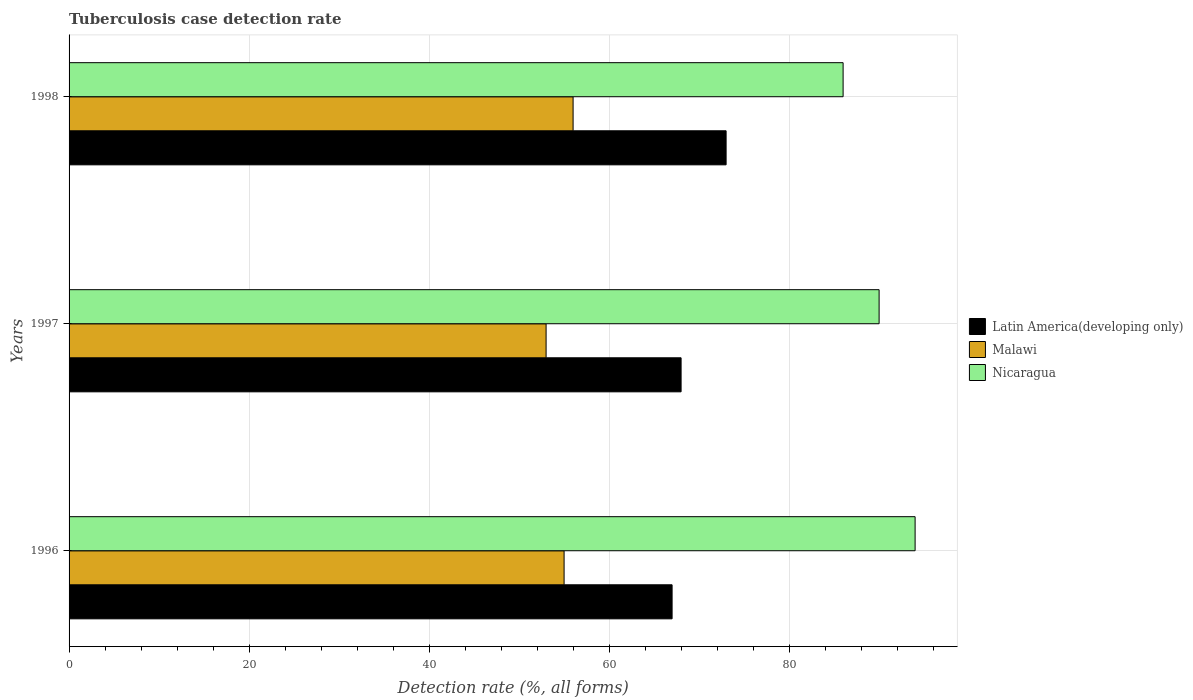How many different coloured bars are there?
Offer a terse response. 3. How many groups of bars are there?
Offer a very short reply. 3. Are the number of bars per tick equal to the number of legend labels?
Make the answer very short. Yes. In how many cases, is the number of bars for a given year not equal to the number of legend labels?
Give a very brief answer. 0. What is the tuberculosis case detection rate in in Nicaragua in 1998?
Your answer should be very brief. 86. Across all years, what is the maximum tuberculosis case detection rate in in Malawi?
Ensure brevity in your answer.  56. Across all years, what is the minimum tuberculosis case detection rate in in Malawi?
Provide a short and direct response. 53. What is the total tuberculosis case detection rate in in Nicaragua in the graph?
Make the answer very short. 270. What is the difference between the tuberculosis case detection rate in in Nicaragua in 1996 and that in 1998?
Offer a terse response. 8. What is the difference between the tuberculosis case detection rate in in Latin America(developing only) in 1996 and the tuberculosis case detection rate in in Malawi in 1998?
Your response must be concise. 11. What is the average tuberculosis case detection rate in in Latin America(developing only) per year?
Provide a succinct answer. 69.33. In the year 1998, what is the difference between the tuberculosis case detection rate in in Latin America(developing only) and tuberculosis case detection rate in in Nicaragua?
Ensure brevity in your answer.  -13. In how many years, is the tuberculosis case detection rate in in Nicaragua greater than 68 %?
Your response must be concise. 3. What is the ratio of the tuberculosis case detection rate in in Latin America(developing only) in 1996 to that in 1998?
Make the answer very short. 0.92. Is the tuberculosis case detection rate in in Nicaragua in 1996 less than that in 1997?
Offer a terse response. No. What is the difference between the highest and the second highest tuberculosis case detection rate in in Latin America(developing only)?
Give a very brief answer. 5. What is the difference between the highest and the lowest tuberculosis case detection rate in in Latin America(developing only)?
Keep it short and to the point. 6. Is the sum of the tuberculosis case detection rate in in Nicaragua in 1996 and 1997 greater than the maximum tuberculosis case detection rate in in Latin America(developing only) across all years?
Make the answer very short. Yes. What does the 2nd bar from the top in 1996 represents?
Provide a succinct answer. Malawi. What does the 1st bar from the bottom in 1997 represents?
Provide a succinct answer. Latin America(developing only). What is the difference between two consecutive major ticks on the X-axis?
Offer a terse response. 20. Are the values on the major ticks of X-axis written in scientific E-notation?
Ensure brevity in your answer.  No. Does the graph contain grids?
Offer a very short reply. Yes. What is the title of the graph?
Offer a very short reply. Tuberculosis case detection rate. What is the label or title of the X-axis?
Make the answer very short. Detection rate (%, all forms). What is the Detection rate (%, all forms) in Nicaragua in 1996?
Provide a short and direct response. 94. What is the Detection rate (%, all forms) in Malawi in 1997?
Your answer should be very brief. 53. What is the Detection rate (%, all forms) of Nicaragua in 1997?
Your answer should be compact. 90. What is the Detection rate (%, all forms) in Nicaragua in 1998?
Give a very brief answer. 86. Across all years, what is the maximum Detection rate (%, all forms) in Latin America(developing only)?
Give a very brief answer. 73. Across all years, what is the maximum Detection rate (%, all forms) of Malawi?
Your response must be concise. 56. Across all years, what is the maximum Detection rate (%, all forms) of Nicaragua?
Your answer should be compact. 94. What is the total Detection rate (%, all forms) in Latin America(developing only) in the graph?
Your answer should be very brief. 208. What is the total Detection rate (%, all forms) in Malawi in the graph?
Offer a very short reply. 164. What is the total Detection rate (%, all forms) of Nicaragua in the graph?
Make the answer very short. 270. What is the difference between the Detection rate (%, all forms) of Latin America(developing only) in 1996 and that in 1997?
Offer a terse response. -1. What is the difference between the Detection rate (%, all forms) in Malawi in 1996 and that in 1997?
Keep it short and to the point. 2. What is the difference between the Detection rate (%, all forms) of Nicaragua in 1996 and that in 1997?
Provide a short and direct response. 4. What is the difference between the Detection rate (%, all forms) of Latin America(developing only) in 1996 and that in 1998?
Make the answer very short. -6. What is the difference between the Detection rate (%, all forms) in Nicaragua in 1997 and that in 1998?
Provide a succinct answer. 4. What is the difference between the Detection rate (%, all forms) in Latin America(developing only) in 1996 and the Detection rate (%, all forms) in Nicaragua in 1997?
Your response must be concise. -23. What is the difference between the Detection rate (%, all forms) of Malawi in 1996 and the Detection rate (%, all forms) of Nicaragua in 1997?
Your response must be concise. -35. What is the difference between the Detection rate (%, all forms) in Latin America(developing only) in 1996 and the Detection rate (%, all forms) in Malawi in 1998?
Give a very brief answer. 11. What is the difference between the Detection rate (%, all forms) in Malawi in 1996 and the Detection rate (%, all forms) in Nicaragua in 1998?
Offer a terse response. -31. What is the difference between the Detection rate (%, all forms) in Latin America(developing only) in 1997 and the Detection rate (%, all forms) in Nicaragua in 1998?
Give a very brief answer. -18. What is the difference between the Detection rate (%, all forms) of Malawi in 1997 and the Detection rate (%, all forms) of Nicaragua in 1998?
Offer a very short reply. -33. What is the average Detection rate (%, all forms) of Latin America(developing only) per year?
Your answer should be very brief. 69.33. What is the average Detection rate (%, all forms) in Malawi per year?
Provide a succinct answer. 54.67. What is the average Detection rate (%, all forms) of Nicaragua per year?
Your answer should be very brief. 90. In the year 1996, what is the difference between the Detection rate (%, all forms) of Malawi and Detection rate (%, all forms) of Nicaragua?
Make the answer very short. -39. In the year 1997, what is the difference between the Detection rate (%, all forms) in Malawi and Detection rate (%, all forms) in Nicaragua?
Make the answer very short. -37. In the year 1998, what is the difference between the Detection rate (%, all forms) of Latin America(developing only) and Detection rate (%, all forms) of Malawi?
Your response must be concise. 17. In the year 1998, what is the difference between the Detection rate (%, all forms) of Malawi and Detection rate (%, all forms) of Nicaragua?
Your response must be concise. -30. What is the ratio of the Detection rate (%, all forms) of Malawi in 1996 to that in 1997?
Your answer should be very brief. 1.04. What is the ratio of the Detection rate (%, all forms) in Nicaragua in 1996 to that in 1997?
Offer a very short reply. 1.04. What is the ratio of the Detection rate (%, all forms) of Latin America(developing only) in 1996 to that in 1998?
Ensure brevity in your answer.  0.92. What is the ratio of the Detection rate (%, all forms) in Malawi in 1996 to that in 1998?
Provide a short and direct response. 0.98. What is the ratio of the Detection rate (%, all forms) in Nicaragua in 1996 to that in 1998?
Your answer should be compact. 1.09. What is the ratio of the Detection rate (%, all forms) in Latin America(developing only) in 1997 to that in 1998?
Your answer should be compact. 0.93. What is the ratio of the Detection rate (%, all forms) in Malawi in 1997 to that in 1998?
Provide a short and direct response. 0.95. What is the ratio of the Detection rate (%, all forms) in Nicaragua in 1997 to that in 1998?
Ensure brevity in your answer.  1.05. What is the difference between the highest and the lowest Detection rate (%, all forms) in Latin America(developing only)?
Provide a short and direct response. 6. What is the difference between the highest and the lowest Detection rate (%, all forms) of Malawi?
Your answer should be very brief. 3. 